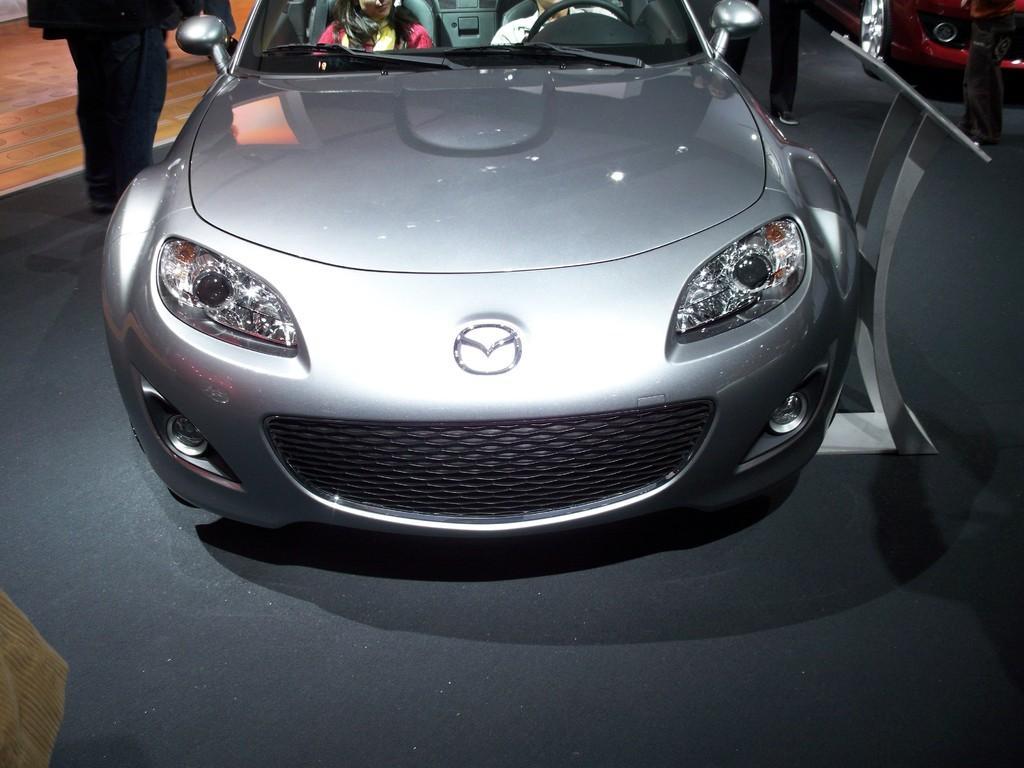Could you give a brief overview of what you see in this image? In this picture we can see a car on the floor with two people sitting in it, stand, vehicle and some people. 